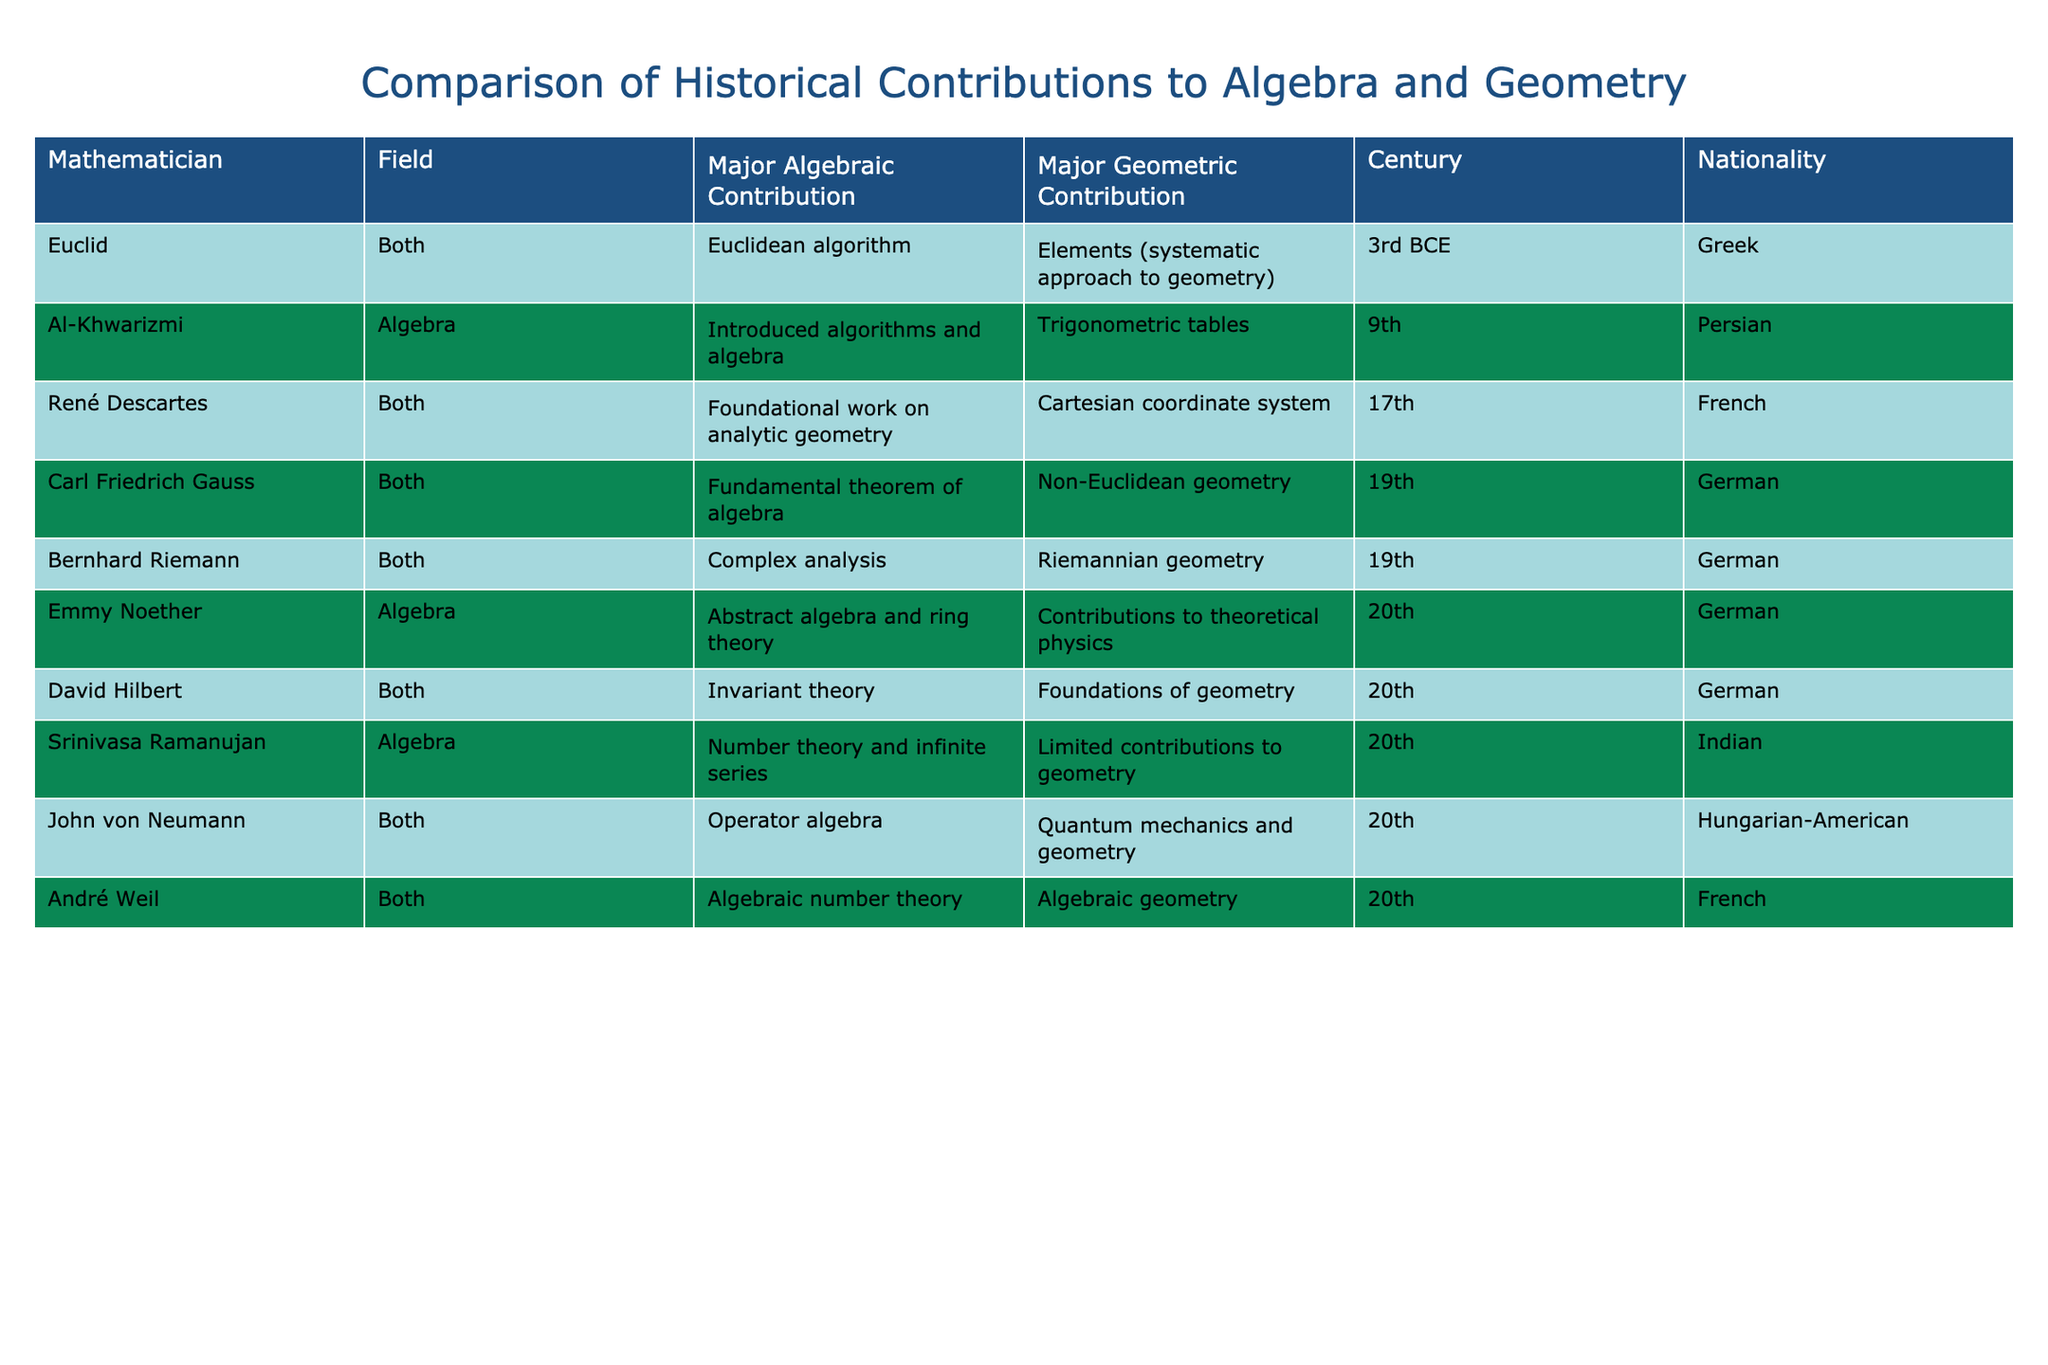What major algebraic contribution is associated with Carl Friedrich Gauss? The table shows "Fundamental theorem of algebra" listed under the Major Algebraic Contribution for Carl Friedrich Gauss.
Answer: Fundamental theorem of algebra Which mathematician is known for their foundational work on analytic geometry? The table states that René Descartes made a foundational work on analytic geometry.
Answer: René Descartes How many mathematicians in the table contributed to both algebra and geometry? By counting the rows in the table that list both algebra and geometry, we find there are 6 mathematicians: Euclid, René Descartes, Carl Friedrich Gauss, Bernhard Riemann, David Hilbert, and John von Neumann.
Answer: 6 Is Emmy Noether's major contribution to geometry significant according to the table? The table indicates that Emmy Noether's major geometric contribution is "Contributions to theoretical physics," which is not a specific geometric contribution, suggesting it is not significant in the context of geometry.
Answer: No Which century had the most mathematicians listed in the table, contributing to both algebra and geometry? By examining the centuries for those who contributed to both fields, the 20th century has 4 mathematicians (Emmy Noether, David Hilbert, John von Neumann, and André Weil), whereas other centuries have fewer or none. Therefore, the 20th century had the most.
Answer: 20th century What’s the average century of contribution for the mathematicians who only focused on algebra? The mathematicians focused solely on algebra are Al-Khwarizmi (9th), Emmy Noether (20th), and Srinivasa Ramanujan (20th). The average can be calculated as (9 + 20 + 20) / 3 = 16.33, which suggests that the average century of contribution is in the 16th.
Answer: 16.33 Did any mathematicians contribute to both algebra and geometry in the 19th century? The table lists Carl Friedrich Gauss and Bernhard Riemann as both contributing to algebra and geometry in the 19th century, confirming that there were indeed contributions in this century for both fields.
Answer: Yes What are the major contributions to geometry made by André Weil? The table shows that André Weil's major contribution to geometry is "Algebraic geometry," explicitly reflecting his work in that field.
Answer: Algebraic geometry 